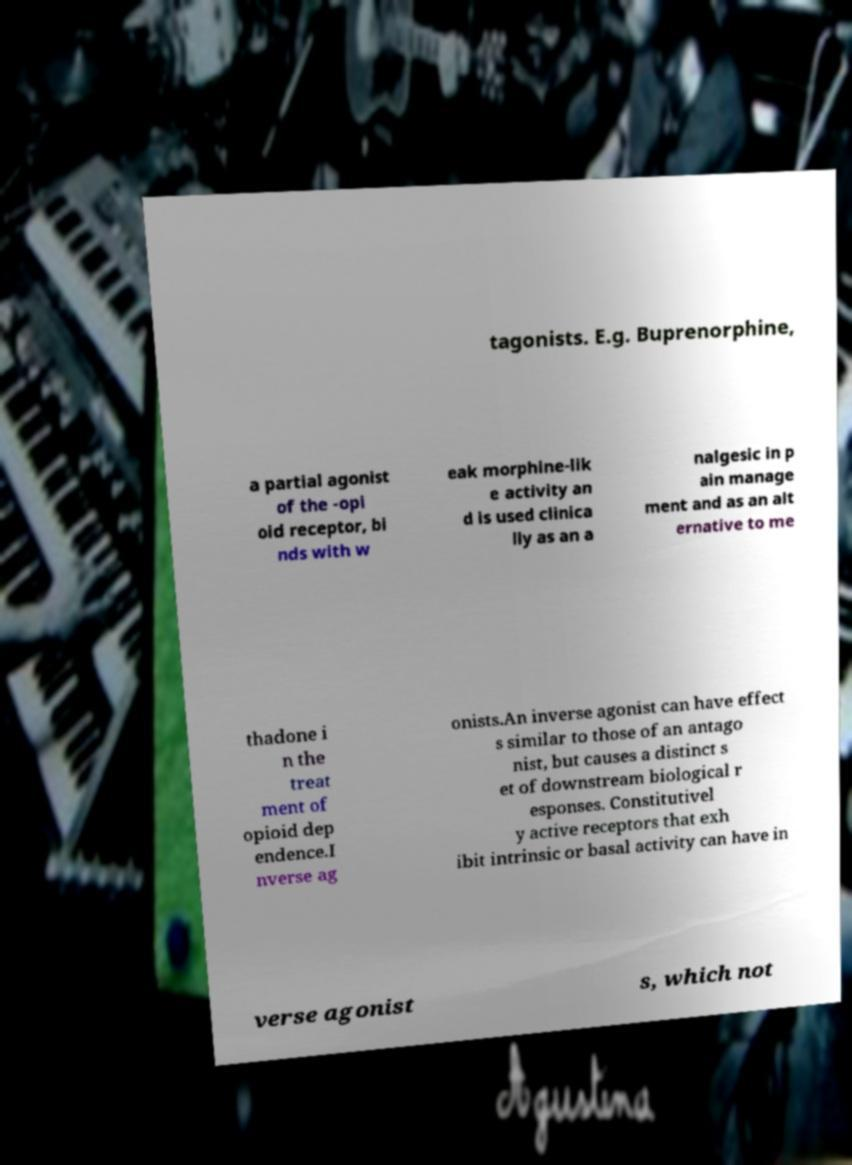Please read and relay the text visible in this image. What does it say? tagonists. E.g. Buprenorphine, a partial agonist of the -opi oid receptor, bi nds with w eak morphine-lik e activity an d is used clinica lly as an a nalgesic in p ain manage ment and as an alt ernative to me thadone i n the treat ment of opioid dep endence.I nverse ag onists.An inverse agonist can have effect s similar to those of an antago nist, but causes a distinct s et of downstream biological r esponses. Constitutivel y active receptors that exh ibit intrinsic or basal activity can have in verse agonist s, which not 